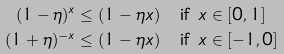Convert formula to latex. <formula><loc_0><loc_0><loc_500><loc_500>( 1 - \eta ) ^ { x } \leq ( 1 - \eta x ) & \quad \text {if\ } x \in [ 0 , 1 ] \\ ( 1 + \eta ) ^ { - x } \leq ( 1 - \eta x ) & \quad \text {if\ } x \in [ - 1 , 0 ]</formula> 